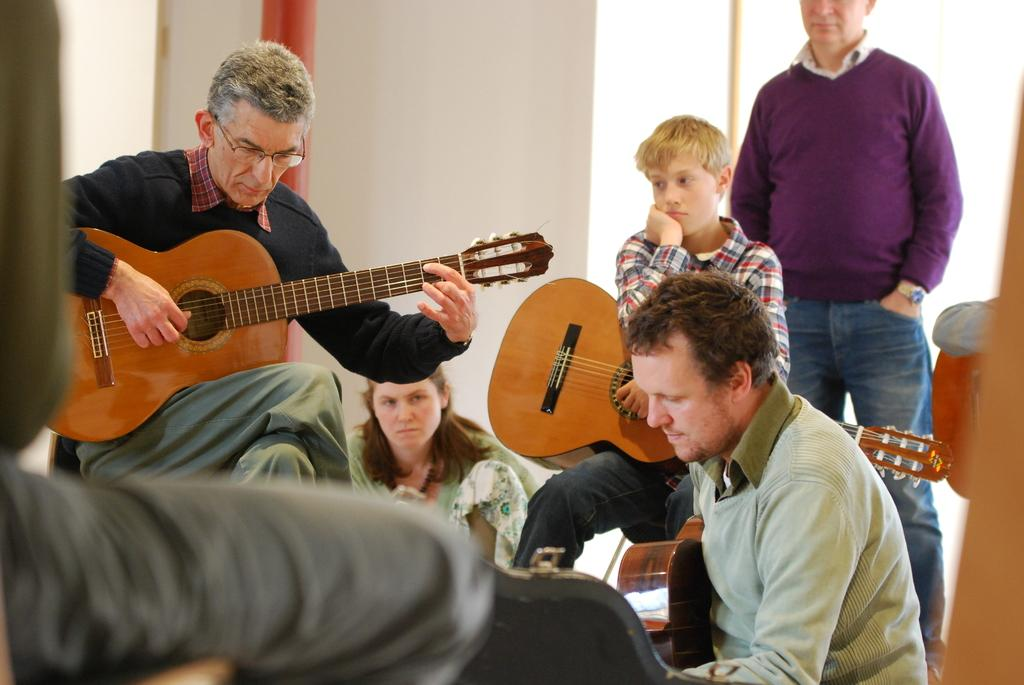What is the person on the left side of the image doing? The person on the left side of the image is playing a guitar. Who is behind the person playing the guitar? There is a woman behind the person playing the guitar. What can be seen behind the woman? There is a wall behind the woman. What is the person on the right side of the image doing? The person on the right side of the image is holding a guitar. Who is behind the person holding the guitar? There is a man behind the person holding the guitar. How many people are in the front of the image? There are two persons in the front of the image. How does the person playing the guitar measure the balance of the guitar in the image? There is no indication in the image that the person playing the guitar is measuring the balance of the guitar. What type of cover is on the guitar held by the person on the right side of the image? The image does not show any covers on the guitar held by the person on the right side of the image. 